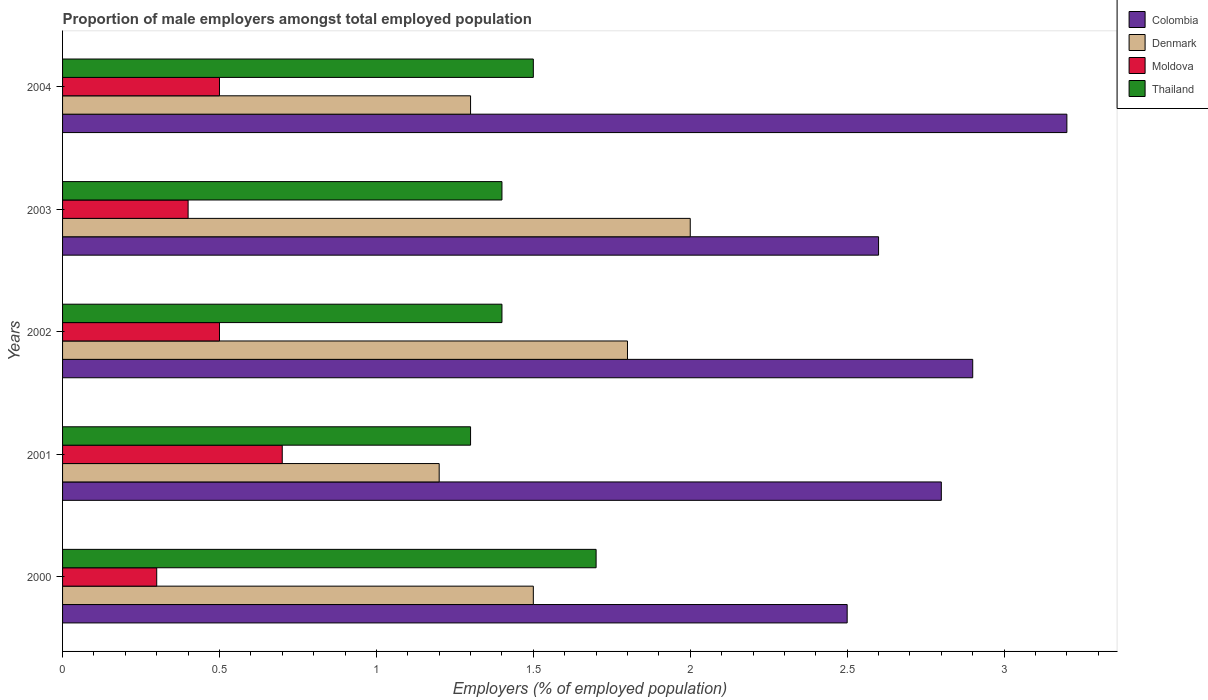How many different coloured bars are there?
Your answer should be compact. 4. How many groups of bars are there?
Offer a very short reply. 5. How many bars are there on the 3rd tick from the bottom?
Provide a succinct answer. 4. What is the proportion of male employers in Thailand in 2001?
Ensure brevity in your answer.  1.3. Across all years, what is the maximum proportion of male employers in Thailand?
Keep it short and to the point. 1.7. Across all years, what is the minimum proportion of male employers in Thailand?
Offer a very short reply. 1.3. What is the total proportion of male employers in Denmark in the graph?
Make the answer very short. 7.8. What is the difference between the proportion of male employers in Colombia in 2002 and that in 2004?
Keep it short and to the point. -0.3. What is the difference between the proportion of male employers in Moldova in 2004 and the proportion of male employers in Thailand in 2001?
Keep it short and to the point. -0.8. What is the average proportion of male employers in Denmark per year?
Provide a short and direct response. 1.56. In the year 2001, what is the difference between the proportion of male employers in Colombia and proportion of male employers in Thailand?
Make the answer very short. 1.5. In how many years, is the proportion of male employers in Denmark greater than 2.3 %?
Provide a succinct answer. 0. What is the ratio of the proportion of male employers in Denmark in 2002 to that in 2004?
Provide a short and direct response. 1.38. Is the proportion of male employers in Moldova in 2000 less than that in 2004?
Keep it short and to the point. Yes. What is the difference between the highest and the second highest proportion of male employers in Moldova?
Keep it short and to the point. 0.2. What is the difference between the highest and the lowest proportion of male employers in Colombia?
Keep it short and to the point. 0.7. In how many years, is the proportion of male employers in Colombia greater than the average proportion of male employers in Colombia taken over all years?
Your answer should be compact. 2. Is the sum of the proportion of male employers in Moldova in 2000 and 2002 greater than the maximum proportion of male employers in Colombia across all years?
Give a very brief answer. No. What does the 2nd bar from the bottom in 2003 represents?
Offer a terse response. Denmark. Is it the case that in every year, the sum of the proportion of male employers in Thailand and proportion of male employers in Denmark is greater than the proportion of male employers in Colombia?
Make the answer very short. No. How many bars are there?
Provide a succinct answer. 20. Are all the bars in the graph horizontal?
Provide a succinct answer. Yes. What is the difference between two consecutive major ticks on the X-axis?
Provide a short and direct response. 0.5. Are the values on the major ticks of X-axis written in scientific E-notation?
Offer a terse response. No. Does the graph contain any zero values?
Your answer should be very brief. No. Does the graph contain grids?
Give a very brief answer. No. How many legend labels are there?
Offer a terse response. 4. How are the legend labels stacked?
Your answer should be compact. Vertical. What is the title of the graph?
Provide a succinct answer. Proportion of male employers amongst total employed population. Does "Fiji" appear as one of the legend labels in the graph?
Provide a succinct answer. No. What is the label or title of the X-axis?
Your answer should be compact. Employers (% of employed population). What is the Employers (% of employed population) of Moldova in 2000?
Offer a very short reply. 0.3. What is the Employers (% of employed population) in Thailand in 2000?
Your answer should be compact. 1.7. What is the Employers (% of employed population) in Colombia in 2001?
Give a very brief answer. 2.8. What is the Employers (% of employed population) in Denmark in 2001?
Give a very brief answer. 1.2. What is the Employers (% of employed population) in Moldova in 2001?
Offer a terse response. 0.7. What is the Employers (% of employed population) in Thailand in 2001?
Offer a terse response. 1.3. What is the Employers (% of employed population) of Colombia in 2002?
Give a very brief answer. 2.9. What is the Employers (% of employed population) in Denmark in 2002?
Ensure brevity in your answer.  1.8. What is the Employers (% of employed population) of Thailand in 2002?
Keep it short and to the point. 1.4. What is the Employers (% of employed population) in Colombia in 2003?
Your answer should be compact. 2.6. What is the Employers (% of employed population) in Denmark in 2003?
Your response must be concise. 2. What is the Employers (% of employed population) of Moldova in 2003?
Provide a succinct answer. 0.4. What is the Employers (% of employed population) in Thailand in 2003?
Your response must be concise. 1.4. What is the Employers (% of employed population) of Colombia in 2004?
Make the answer very short. 3.2. What is the Employers (% of employed population) of Denmark in 2004?
Offer a terse response. 1.3. What is the Employers (% of employed population) in Moldova in 2004?
Offer a terse response. 0.5. What is the Employers (% of employed population) of Thailand in 2004?
Offer a terse response. 1.5. Across all years, what is the maximum Employers (% of employed population) in Colombia?
Offer a very short reply. 3.2. Across all years, what is the maximum Employers (% of employed population) in Moldova?
Ensure brevity in your answer.  0.7. Across all years, what is the maximum Employers (% of employed population) in Thailand?
Make the answer very short. 1.7. Across all years, what is the minimum Employers (% of employed population) of Denmark?
Your response must be concise. 1.2. Across all years, what is the minimum Employers (% of employed population) in Moldova?
Offer a very short reply. 0.3. Across all years, what is the minimum Employers (% of employed population) in Thailand?
Provide a short and direct response. 1.3. What is the total Employers (% of employed population) of Moldova in the graph?
Your response must be concise. 2.4. What is the total Employers (% of employed population) of Thailand in the graph?
Ensure brevity in your answer.  7.3. What is the difference between the Employers (% of employed population) of Moldova in 2000 and that in 2001?
Provide a succinct answer. -0.4. What is the difference between the Employers (% of employed population) of Colombia in 2000 and that in 2002?
Provide a succinct answer. -0.4. What is the difference between the Employers (% of employed population) of Thailand in 2000 and that in 2002?
Ensure brevity in your answer.  0.3. What is the difference between the Employers (% of employed population) in Colombia in 2000 and that in 2003?
Your answer should be very brief. -0.1. What is the difference between the Employers (% of employed population) in Denmark in 2000 and that in 2003?
Offer a very short reply. -0.5. What is the difference between the Employers (% of employed population) in Thailand in 2000 and that in 2003?
Offer a very short reply. 0.3. What is the difference between the Employers (% of employed population) of Colombia in 2001 and that in 2002?
Provide a succinct answer. -0.1. What is the difference between the Employers (% of employed population) of Moldova in 2001 and that in 2002?
Offer a very short reply. 0.2. What is the difference between the Employers (% of employed population) in Thailand in 2001 and that in 2002?
Ensure brevity in your answer.  -0.1. What is the difference between the Employers (% of employed population) of Colombia in 2001 and that in 2003?
Offer a very short reply. 0.2. What is the difference between the Employers (% of employed population) of Moldova in 2001 and that in 2003?
Your answer should be very brief. 0.3. What is the difference between the Employers (% of employed population) in Moldova in 2001 and that in 2004?
Provide a succinct answer. 0.2. What is the difference between the Employers (% of employed population) in Thailand in 2001 and that in 2004?
Give a very brief answer. -0.2. What is the difference between the Employers (% of employed population) in Denmark in 2002 and that in 2003?
Your answer should be very brief. -0.2. What is the difference between the Employers (% of employed population) in Thailand in 2002 and that in 2003?
Offer a very short reply. 0. What is the difference between the Employers (% of employed population) of Colombia in 2002 and that in 2004?
Ensure brevity in your answer.  -0.3. What is the difference between the Employers (% of employed population) of Moldova in 2003 and that in 2004?
Your answer should be compact. -0.1. What is the difference between the Employers (% of employed population) of Colombia in 2000 and the Employers (% of employed population) of Denmark in 2001?
Provide a succinct answer. 1.3. What is the difference between the Employers (% of employed population) of Colombia in 2000 and the Employers (% of employed population) of Moldova in 2001?
Make the answer very short. 1.8. What is the difference between the Employers (% of employed population) of Denmark in 2000 and the Employers (% of employed population) of Thailand in 2001?
Your response must be concise. 0.2. What is the difference between the Employers (% of employed population) of Colombia in 2000 and the Employers (% of employed population) of Denmark in 2002?
Your answer should be very brief. 0.7. What is the difference between the Employers (% of employed population) in Denmark in 2000 and the Employers (% of employed population) in Moldova in 2002?
Ensure brevity in your answer.  1. What is the difference between the Employers (% of employed population) in Colombia in 2000 and the Employers (% of employed population) in Moldova in 2003?
Offer a terse response. 2.1. What is the difference between the Employers (% of employed population) of Colombia in 2000 and the Employers (% of employed population) of Thailand in 2003?
Provide a succinct answer. 1.1. What is the difference between the Employers (% of employed population) in Denmark in 2000 and the Employers (% of employed population) in Moldova in 2003?
Give a very brief answer. 1.1. What is the difference between the Employers (% of employed population) of Colombia in 2000 and the Employers (% of employed population) of Thailand in 2004?
Provide a succinct answer. 1. What is the difference between the Employers (% of employed population) of Denmark in 2000 and the Employers (% of employed population) of Moldova in 2004?
Your answer should be compact. 1. What is the difference between the Employers (% of employed population) in Moldova in 2000 and the Employers (% of employed population) in Thailand in 2004?
Provide a succinct answer. -1.2. What is the difference between the Employers (% of employed population) of Colombia in 2001 and the Employers (% of employed population) of Denmark in 2002?
Offer a very short reply. 1. What is the difference between the Employers (% of employed population) in Denmark in 2001 and the Employers (% of employed population) in Moldova in 2002?
Keep it short and to the point. 0.7. What is the difference between the Employers (% of employed population) in Moldova in 2001 and the Employers (% of employed population) in Thailand in 2002?
Offer a terse response. -0.7. What is the difference between the Employers (% of employed population) in Colombia in 2001 and the Employers (% of employed population) in Denmark in 2004?
Your answer should be very brief. 1.5. What is the difference between the Employers (% of employed population) in Colombia in 2001 and the Employers (% of employed population) in Moldova in 2004?
Ensure brevity in your answer.  2.3. What is the difference between the Employers (% of employed population) of Colombia in 2001 and the Employers (% of employed population) of Thailand in 2004?
Your response must be concise. 1.3. What is the difference between the Employers (% of employed population) of Denmark in 2001 and the Employers (% of employed population) of Moldova in 2004?
Your answer should be compact. 0.7. What is the difference between the Employers (% of employed population) in Moldova in 2001 and the Employers (% of employed population) in Thailand in 2004?
Your answer should be compact. -0.8. What is the difference between the Employers (% of employed population) in Colombia in 2002 and the Employers (% of employed population) in Moldova in 2003?
Ensure brevity in your answer.  2.5. What is the difference between the Employers (% of employed population) in Colombia in 2002 and the Employers (% of employed population) in Thailand in 2003?
Offer a very short reply. 1.5. What is the difference between the Employers (% of employed population) of Denmark in 2002 and the Employers (% of employed population) of Moldova in 2003?
Provide a succinct answer. 1.4. What is the difference between the Employers (% of employed population) of Moldova in 2002 and the Employers (% of employed population) of Thailand in 2003?
Make the answer very short. -0.9. What is the difference between the Employers (% of employed population) of Colombia in 2002 and the Employers (% of employed population) of Denmark in 2004?
Keep it short and to the point. 1.6. What is the difference between the Employers (% of employed population) in Colombia in 2002 and the Employers (% of employed population) in Thailand in 2004?
Offer a terse response. 1.4. What is the difference between the Employers (% of employed population) in Denmark in 2002 and the Employers (% of employed population) in Moldova in 2004?
Your response must be concise. 1.3. What is the difference between the Employers (% of employed population) in Denmark in 2002 and the Employers (% of employed population) in Thailand in 2004?
Keep it short and to the point. 0.3. What is the difference between the Employers (% of employed population) of Colombia in 2003 and the Employers (% of employed population) of Denmark in 2004?
Provide a succinct answer. 1.3. What is the difference between the Employers (% of employed population) of Colombia in 2003 and the Employers (% of employed population) of Thailand in 2004?
Your response must be concise. 1.1. What is the average Employers (% of employed population) of Denmark per year?
Ensure brevity in your answer.  1.56. What is the average Employers (% of employed population) in Moldova per year?
Keep it short and to the point. 0.48. What is the average Employers (% of employed population) in Thailand per year?
Offer a very short reply. 1.46. In the year 2000, what is the difference between the Employers (% of employed population) of Colombia and Employers (% of employed population) of Moldova?
Offer a terse response. 2.2. In the year 2000, what is the difference between the Employers (% of employed population) of Denmark and Employers (% of employed population) of Thailand?
Offer a very short reply. -0.2. In the year 2001, what is the difference between the Employers (% of employed population) of Denmark and Employers (% of employed population) of Moldova?
Offer a terse response. 0.5. In the year 2002, what is the difference between the Employers (% of employed population) in Denmark and Employers (% of employed population) in Thailand?
Your response must be concise. 0.4. In the year 2002, what is the difference between the Employers (% of employed population) in Moldova and Employers (% of employed population) in Thailand?
Ensure brevity in your answer.  -0.9. In the year 2003, what is the difference between the Employers (% of employed population) of Colombia and Employers (% of employed population) of Moldova?
Ensure brevity in your answer.  2.2. In the year 2003, what is the difference between the Employers (% of employed population) in Moldova and Employers (% of employed population) in Thailand?
Keep it short and to the point. -1. In the year 2004, what is the difference between the Employers (% of employed population) of Colombia and Employers (% of employed population) of Denmark?
Offer a very short reply. 1.9. In the year 2004, what is the difference between the Employers (% of employed population) in Denmark and Employers (% of employed population) in Moldova?
Your response must be concise. 0.8. What is the ratio of the Employers (% of employed population) of Colombia in 2000 to that in 2001?
Ensure brevity in your answer.  0.89. What is the ratio of the Employers (% of employed population) in Moldova in 2000 to that in 2001?
Give a very brief answer. 0.43. What is the ratio of the Employers (% of employed population) of Thailand in 2000 to that in 2001?
Provide a succinct answer. 1.31. What is the ratio of the Employers (% of employed population) of Colombia in 2000 to that in 2002?
Your answer should be very brief. 0.86. What is the ratio of the Employers (% of employed population) in Denmark in 2000 to that in 2002?
Provide a short and direct response. 0.83. What is the ratio of the Employers (% of employed population) of Thailand in 2000 to that in 2002?
Ensure brevity in your answer.  1.21. What is the ratio of the Employers (% of employed population) of Colombia in 2000 to that in 2003?
Give a very brief answer. 0.96. What is the ratio of the Employers (% of employed population) in Denmark in 2000 to that in 2003?
Your response must be concise. 0.75. What is the ratio of the Employers (% of employed population) in Thailand in 2000 to that in 2003?
Offer a terse response. 1.21. What is the ratio of the Employers (% of employed population) of Colombia in 2000 to that in 2004?
Make the answer very short. 0.78. What is the ratio of the Employers (% of employed population) of Denmark in 2000 to that in 2004?
Your answer should be very brief. 1.15. What is the ratio of the Employers (% of employed population) in Moldova in 2000 to that in 2004?
Your answer should be compact. 0.6. What is the ratio of the Employers (% of employed population) of Thailand in 2000 to that in 2004?
Your answer should be very brief. 1.13. What is the ratio of the Employers (% of employed population) in Colombia in 2001 to that in 2002?
Offer a terse response. 0.97. What is the ratio of the Employers (% of employed population) in Denmark in 2001 to that in 2003?
Provide a succinct answer. 0.6. What is the ratio of the Employers (% of employed population) of Moldova in 2001 to that in 2003?
Make the answer very short. 1.75. What is the ratio of the Employers (% of employed population) in Thailand in 2001 to that in 2003?
Keep it short and to the point. 0.93. What is the ratio of the Employers (% of employed population) of Colombia in 2001 to that in 2004?
Offer a terse response. 0.88. What is the ratio of the Employers (% of employed population) of Denmark in 2001 to that in 2004?
Your answer should be compact. 0.92. What is the ratio of the Employers (% of employed population) of Moldova in 2001 to that in 2004?
Your response must be concise. 1.4. What is the ratio of the Employers (% of employed population) in Thailand in 2001 to that in 2004?
Offer a terse response. 0.87. What is the ratio of the Employers (% of employed population) in Colombia in 2002 to that in 2003?
Your answer should be compact. 1.12. What is the ratio of the Employers (% of employed population) of Denmark in 2002 to that in 2003?
Provide a short and direct response. 0.9. What is the ratio of the Employers (% of employed population) of Moldova in 2002 to that in 2003?
Your response must be concise. 1.25. What is the ratio of the Employers (% of employed population) in Thailand in 2002 to that in 2003?
Ensure brevity in your answer.  1. What is the ratio of the Employers (% of employed population) in Colombia in 2002 to that in 2004?
Your answer should be compact. 0.91. What is the ratio of the Employers (% of employed population) of Denmark in 2002 to that in 2004?
Offer a terse response. 1.38. What is the ratio of the Employers (% of employed population) of Thailand in 2002 to that in 2004?
Your answer should be compact. 0.93. What is the ratio of the Employers (% of employed population) in Colombia in 2003 to that in 2004?
Ensure brevity in your answer.  0.81. What is the ratio of the Employers (% of employed population) in Denmark in 2003 to that in 2004?
Ensure brevity in your answer.  1.54. What is the ratio of the Employers (% of employed population) in Thailand in 2003 to that in 2004?
Your answer should be compact. 0.93. What is the difference between the highest and the second highest Employers (% of employed population) of Moldova?
Offer a very short reply. 0.2. What is the difference between the highest and the second highest Employers (% of employed population) in Thailand?
Give a very brief answer. 0.2. What is the difference between the highest and the lowest Employers (% of employed population) of Moldova?
Your response must be concise. 0.4. 